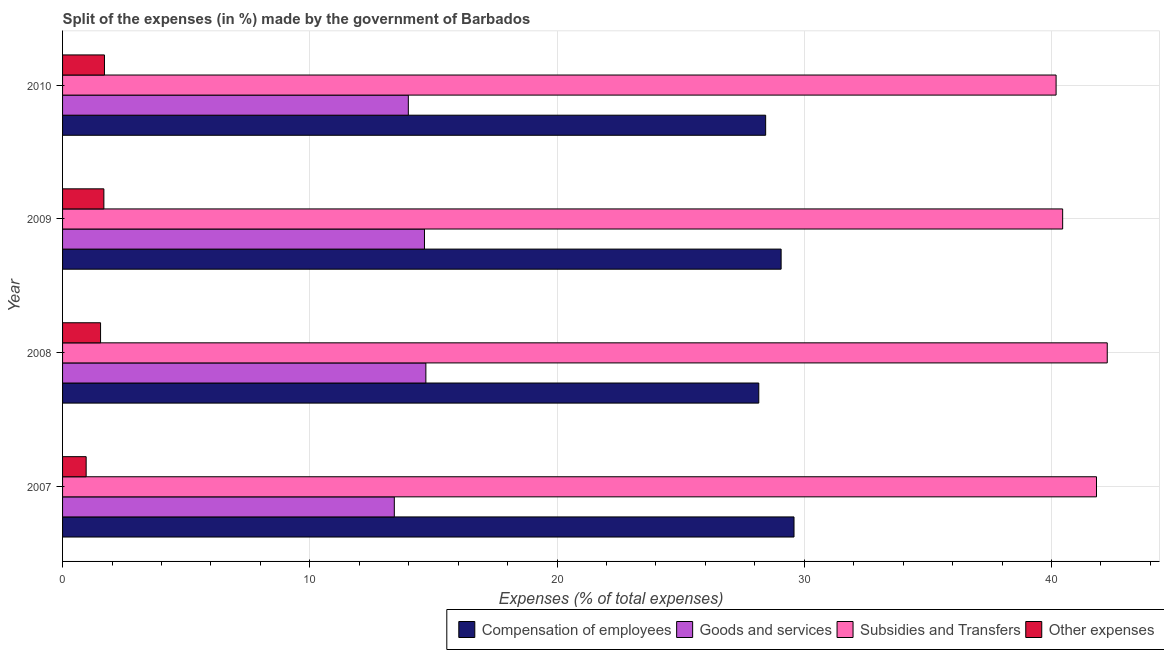How many groups of bars are there?
Offer a very short reply. 4. Are the number of bars per tick equal to the number of legend labels?
Ensure brevity in your answer.  Yes. Are the number of bars on each tick of the Y-axis equal?
Your answer should be very brief. Yes. How many bars are there on the 2nd tick from the top?
Offer a very short reply. 4. What is the label of the 1st group of bars from the top?
Ensure brevity in your answer.  2010. What is the percentage of amount spent on goods and services in 2010?
Make the answer very short. 13.99. Across all years, what is the maximum percentage of amount spent on compensation of employees?
Provide a short and direct response. 29.59. Across all years, what is the minimum percentage of amount spent on other expenses?
Provide a short and direct response. 0.95. What is the total percentage of amount spent on other expenses in the graph?
Offer a very short reply. 5.86. What is the difference between the percentage of amount spent on subsidies in 2008 and that in 2010?
Make the answer very short. 2.07. What is the difference between the percentage of amount spent on subsidies in 2009 and the percentage of amount spent on goods and services in 2008?
Keep it short and to the point. 25.76. What is the average percentage of amount spent on compensation of employees per year?
Keep it short and to the point. 28.81. In the year 2009, what is the difference between the percentage of amount spent on other expenses and percentage of amount spent on compensation of employees?
Keep it short and to the point. -27.39. What is the ratio of the percentage of amount spent on subsidies in 2007 to that in 2009?
Provide a succinct answer. 1.03. Is the percentage of amount spent on compensation of employees in 2007 less than that in 2009?
Provide a succinct answer. No. What is the difference between the highest and the second highest percentage of amount spent on goods and services?
Offer a terse response. 0.06. What is the difference between the highest and the lowest percentage of amount spent on goods and services?
Your response must be concise. 1.28. In how many years, is the percentage of amount spent on goods and services greater than the average percentage of amount spent on goods and services taken over all years?
Provide a succinct answer. 2. Is the sum of the percentage of amount spent on goods and services in 2009 and 2010 greater than the maximum percentage of amount spent on compensation of employees across all years?
Your response must be concise. No. What does the 1st bar from the top in 2008 represents?
Your answer should be very brief. Other expenses. What does the 3rd bar from the bottom in 2010 represents?
Your response must be concise. Subsidies and Transfers. Is it the case that in every year, the sum of the percentage of amount spent on compensation of employees and percentage of amount spent on goods and services is greater than the percentage of amount spent on subsidies?
Give a very brief answer. Yes. Are all the bars in the graph horizontal?
Your answer should be very brief. Yes. What is the difference between two consecutive major ticks on the X-axis?
Your response must be concise. 10. Are the values on the major ticks of X-axis written in scientific E-notation?
Offer a terse response. No. Does the graph contain grids?
Make the answer very short. Yes. Where does the legend appear in the graph?
Your answer should be very brief. Bottom right. How many legend labels are there?
Your answer should be compact. 4. How are the legend labels stacked?
Provide a short and direct response. Horizontal. What is the title of the graph?
Make the answer very short. Split of the expenses (in %) made by the government of Barbados. What is the label or title of the X-axis?
Your answer should be compact. Expenses (% of total expenses). What is the label or title of the Y-axis?
Make the answer very short. Year. What is the Expenses (% of total expenses) of Compensation of employees in 2007?
Your answer should be compact. 29.59. What is the Expenses (% of total expenses) of Goods and services in 2007?
Your answer should be compact. 13.42. What is the Expenses (% of total expenses) in Subsidies and Transfers in 2007?
Provide a succinct answer. 41.82. What is the Expenses (% of total expenses) of Other expenses in 2007?
Give a very brief answer. 0.95. What is the Expenses (% of total expenses) of Compensation of employees in 2008?
Your answer should be compact. 28.16. What is the Expenses (% of total expenses) of Goods and services in 2008?
Your answer should be very brief. 14.69. What is the Expenses (% of total expenses) of Subsidies and Transfers in 2008?
Ensure brevity in your answer.  42.26. What is the Expenses (% of total expenses) of Other expenses in 2008?
Your response must be concise. 1.54. What is the Expenses (% of total expenses) of Compensation of employees in 2009?
Give a very brief answer. 29.06. What is the Expenses (% of total expenses) in Goods and services in 2009?
Provide a short and direct response. 14.64. What is the Expenses (% of total expenses) of Subsidies and Transfers in 2009?
Provide a succinct answer. 40.45. What is the Expenses (% of total expenses) of Other expenses in 2009?
Your answer should be compact. 1.67. What is the Expenses (% of total expenses) in Compensation of employees in 2010?
Provide a short and direct response. 28.44. What is the Expenses (% of total expenses) of Goods and services in 2010?
Provide a short and direct response. 13.99. What is the Expenses (% of total expenses) in Subsidies and Transfers in 2010?
Offer a very short reply. 40.19. What is the Expenses (% of total expenses) in Other expenses in 2010?
Provide a short and direct response. 1.69. Across all years, what is the maximum Expenses (% of total expenses) in Compensation of employees?
Ensure brevity in your answer.  29.59. Across all years, what is the maximum Expenses (% of total expenses) of Goods and services?
Your answer should be compact. 14.69. Across all years, what is the maximum Expenses (% of total expenses) in Subsidies and Transfers?
Give a very brief answer. 42.26. Across all years, what is the maximum Expenses (% of total expenses) of Other expenses?
Ensure brevity in your answer.  1.69. Across all years, what is the minimum Expenses (% of total expenses) in Compensation of employees?
Ensure brevity in your answer.  28.16. Across all years, what is the minimum Expenses (% of total expenses) of Goods and services?
Provide a succinct answer. 13.42. Across all years, what is the minimum Expenses (% of total expenses) in Subsidies and Transfers?
Keep it short and to the point. 40.19. Across all years, what is the minimum Expenses (% of total expenses) in Other expenses?
Provide a short and direct response. 0.95. What is the total Expenses (% of total expenses) of Compensation of employees in the graph?
Provide a succinct answer. 115.25. What is the total Expenses (% of total expenses) in Goods and services in the graph?
Make the answer very short. 56.74. What is the total Expenses (% of total expenses) of Subsidies and Transfers in the graph?
Offer a terse response. 164.71. What is the total Expenses (% of total expenses) of Other expenses in the graph?
Make the answer very short. 5.86. What is the difference between the Expenses (% of total expenses) in Compensation of employees in 2007 and that in 2008?
Ensure brevity in your answer.  1.43. What is the difference between the Expenses (% of total expenses) in Goods and services in 2007 and that in 2008?
Ensure brevity in your answer.  -1.28. What is the difference between the Expenses (% of total expenses) in Subsidies and Transfers in 2007 and that in 2008?
Offer a very short reply. -0.44. What is the difference between the Expenses (% of total expenses) of Other expenses in 2007 and that in 2008?
Provide a short and direct response. -0.58. What is the difference between the Expenses (% of total expenses) in Compensation of employees in 2007 and that in 2009?
Keep it short and to the point. 0.52. What is the difference between the Expenses (% of total expenses) of Goods and services in 2007 and that in 2009?
Your answer should be compact. -1.22. What is the difference between the Expenses (% of total expenses) in Subsidies and Transfers in 2007 and that in 2009?
Offer a very short reply. 1.37. What is the difference between the Expenses (% of total expenses) of Other expenses in 2007 and that in 2009?
Provide a succinct answer. -0.72. What is the difference between the Expenses (% of total expenses) in Compensation of employees in 2007 and that in 2010?
Offer a terse response. 1.15. What is the difference between the Expenses (% of total expenses) in Goods and services in 2007 and that in 2010?
Give a very brief answer. -0.57. What is the difference between the Expenses (% of total expenses) of Subsidies and Transfers in 2007 and that in 2010?
Give a very brief answer. 1.63. What is the difference between the Expenses (% of total expenses) in Other expenses in 2007 and that in 2010?
Ensure brevity in your answer.  -0.74. What is the difference between the Expenses (% of total expenses) in Compensation of employees in 2008 and that in 2009?
Your answer should be compact. -0.9. What is the difference between the Expenses (% of total expenses) of Goods and services in 2008 and that in 2009?
Keep it short and to the point. 0.06. What is the difference between the Expenses (% of total expenses) in Subsidies and Transfers in 2008 and that in 2009?
Make the answer very short. 1.8. What is the difference between the Expenses (% of total expenses) of Other expenses in 2008 and that in 2009?
Make the answer very short. -0.13. What is the difference between the Expenses (% of total expenses) of Compensation of employees in 2008 and that in 2010?
Provide a succinct answer. -0.28. What is the difference between the Expenses (% of total expenses) in Goods and services in 2008 and that in 2010?
Keep it short and to the point. 0.71. What is the difference between the Expenses (% of total expenses) of Subsidies and Transfers in 2008 and that in 2010?
Keep it short and to the point. 2.07. What is the difference between the Expenses (% of total expenses) of Other expenses in 2008 and that in 2010?
Offer a very short reply. -0.16. What is the difference between the Expenses (% of total expenses) of Compensation of employees in 2009 and that in 2010?
Ensure brevity in your answer.  0.63. What is the difference between the Expenses (% of total expenses) of Goods and services in 2009 and that in 2010?
Ensure brevity in your answer.  0.65. What is the difference between the Expenses (% of total expenses) in Subsidies and Transfers in 2009 and that in 2010?
Keep it short and to the point. 0.27. What is the difference between the Expenses (% of total expenses) in Other expenses in 2009 and that in 2010?
Provide a short and direct response. -0.02. What is the difference between the Expenses (% of total expenses) in Compensation of employees in 2007 and the Expenses (% of total expenses) in Goods and services in 2008?
Provide a succinct answer. 14.89. What is the difference between the Expenses (% of total expenses) of Compensation of employees in 2007 and the Expenses (% of total expenses) of Subsidies and Transfers in 2008?
Offer a terse response. -12.67. What is the difference between the Expenses (% of total expenses) in Compensation of employees in 2007 and the Expenses (% of total expenses) in Other expenses in 2008?
Make the answer very short. 28.05. What is the difference between the Expenses (% of total expenses) in Goods and services in 2007 and the Expenses (% of total expenses) in Subsidies and Transfers in 2008?
Make the answer very short. -28.84. What is the difference between the Expenses (% of total expenses) of Goods and services in 2007 and the Expenses (% of total expenses) of Other expenses in 2008?
Provide a short and direct response. 11.88. What is the difference between the Expenses (% of total expenses) in Subsidies and Transfers in 2007 and the Expenses (% of total expenses) in Other expenses in 2008?
Make the answer very short. 40.28. What is the difference between the Expenses (% of total expenses) of Compensation of employees in 2007 and the Expenses (% of total expenses) of Goods and services in 2009?
Offer a terse response. 14.95. What is the difference between the Expenses (% of total expenses) of Compensation of employees in 2007 and the Expenses (% of total expenses) of Subsidies and Transfers in 2009?
Your answer should be very brief. -10.87. What is the difference between the Expenses (% of total expenses) in Compensation of employees in 2007 and the Expenses (% of total expenses) in Other expenses in 2009?
Your answer should be very brief. 27.91. What is the difference between the Expenses (% of total expenses) in Goods and services in 2007 and the Expenses (% of total expenses) in Subsidies and Transfers in 2009?
Provide a succinct answer. -27.03. What is the difference between the Expenses (% of total expenses) in Goods and services in 2007 and the Expenses (% of total expenses) in Other expenses in 2009?
Ensure brevity in your answer.  11.75. What is the difference between the Expenses (% of total expenses) of Subsidies and Transfers in 2007 and the Expenses (% of total expenses) of Other expenses in 2009?
Ensure brevity in your answer.  40.15. What is the difference between the Expenses (% of total expenses) of Compensation of employees in 2007 and the Expenses (% of total expenses) of Goods and services in 2010?
Your response must be concise. 15.6. What is the difference between the Expenses (% of total expenses) of Compensation of employees in 2007 and the Expenses (% of total expenses) of Subsidies and Transfers in 2010?
Your answer should be very brief. -10.6. What is the difference between the Expenses (% of total expenses) of Compensation of employees in 2007 and the Expenses (% of total expenses) of Other expenses in 2010?
Offer a terse response. 27.89. What is the difference between the Expenses (% of total expenses) in Goods and services in 2007 and the Expenses (% of total expenses) in Subsidies and Transfers in 2010?
Your response must be concise. -26.77. What is the difference between the Expenses (% of total expenses) in Goods and services in 2007 and the Expenses (% of total expenses) in Other expenses in 2010?
Offer a very short reply. 11.72. What is the difference between the Expenses (% of total expenses) in Subsidies and Transfers in 2007 and the Expenses (% of total expenses) in Other expenses in 2010?
Keep it short and to the point. 40.13. What is the difference between the Expenses (% of total expenses) of Compensation of employees in 2008 and the Expenses (% of total expenses) of Goods and services in 2009?
Give a very brief answer. 13.52. What is the difference between the Expenses (% of total expenses) of Compensation of employees in 2008 and the Expenses (% of total expenses) of Subsidies and Transfers in 2009?
Your answer should be very brief. -12.29. What is the difference between the Expenses (% of total expenses) of Compensation of employees in 2008 and the Expenses (% of total expenses) of Other expenses in 2009?
Your response must be concise. 26.49. What is the difference between the Expenses (% of total expenses) in Goods and services in 2008 and the Expenses (% of total expenses) in Subsidies and Transfers in 2009?
Offer a very short reply. -25.76. What is the difference between the Expenses (% of total expenses) in Goods and services in 2008 and the Expenses (% of total expenses) in Other expenses in 2009?
Keep it short and to the point. 13.02. What is the difference between the Expenses (% of total expenses) of Subsidies and Transfers in 2008 and the Expenses (% of total expenses) of Other expenses in 2009?
Offer a terse response. 40.58. What is the difference between the Expenses (% of total expenses) of Compensation of employees in 2008 and the Expenses (% of total expenses) of Goods and services in 2010?
Offer a terse response. 14.17. What is the difference between the Expenses (% of total expenses) in Compensation of employees in 2008 and the Expenses (% of total expenses) in Subsidies and Transfers in 2010?
Provide a short and direct response. -12.03. What is the difference between the Expenses (% of total expenses) of Compensation of employees in 2008 and the Expenses (% of total expenses) of Other expenses in 2010?
Keep it short and to the point. 26.47. What is the difference between the Expenses (% of total expenses) in Goods and services in 2008 and the Expenses (% of total expenses) in Subsidies and Transfers in 2010?
Offer a very short reply. -25.49. What is the difference between the Expenses (% of total expenses) of Goods and services in 2008 and the Expenses (% of total expenses) of Other expenses in 2010?
Offer a terse response. 13. What is the difference between the Expenses (% of total expenses) of Subsidies and Transfers in 2008 and the Expenses (% of total expenses) of Other expenses in 2010?
Provide a succinct answer. 40.56. What is the difference between the Expenses (% of total expenses) in Compensation of employees in 2009 and the Expenses (% of total expenses) in Goods and services in 2010?
Offer a very short reply. 15.08. What is the difference between the Expenses (% of total expenses) of Compensation of employees in 2009 and the Expenses (% of total expenses) of Subsidies and Transfers in 2010?
Ensure brevity in your answer.  -11.12. What is the difference between the Expenses (% of total expenses) in Compensation of employees in 2009 and the Expenses (% of total expenses) in Other expenses in 2010?
Ensure brevity in your answer.  27.37. What is the difference between the Expenses (% of total expenses) of Goods and services in 2009 and the Expenses (% of total expenses) of Subsidies and Transfers in 2010?
Give a very brief answer. -25.55. What is the difference between the Expenses (% of total expenses) in Goods and services in 2009 and the Expenses (% of total expenses) in Other expenses in 2010?
Your response must be concise. 12.94. What is the difference between the Expenses (% of total expenses) of Subsidies and Transfers in 2009 and the Expenses (% of total expenses) of Other expenses in 2010?
Offer a very short reply. 38.76. What is the average Expenses (% of total expenses) of Compensation of employees per year?
Give a very brief answer. 28.81. What is the average Expenses (% of total expenses) in Goods and services per year?
Your answer should be compact. 14.18. What is the average Expenses (% of total expenses) of Subsidies and Transfers per year?
Ensure brevity in your answer.  41.18. What is the average Expenses (% of total expenses) in Other expenses per year?
Offer a terse response. 1.46. In the year 2007, what is the difference between the Expenses (% of total expenses) of Compensation of employees and Expenses (% of total expenses) of Goods and services?
Ensure brevity in your answer.  16.17. In the year 2007, what is the difference between the Expenses (% of total expenses) in Compensation of employees and Expenses (% of total expenses) in Subsidies and Transfers?
Offer a terse response. -12.23. In the year 2007, what is the difference between the Expenses (% of total expenses) in Compensation of employees and Expenses (% of total expenses) in Other expenses?
Offer a very short reply. 28.63. In the year 2007, what is the difference between the Expenses (% of total expenses) of Goods and services and Expenses (% of total expenses) of Subsidies and Transfers?
Give a very brief answer. -28.4. In the year 2007, what is the difference between the Expenses (% of total expenses) of Goods and services and Expenses (% of total expenses) of Other expenses?
Your response must be concise. 12.46. In the year 2007, what is the difference between the Expenses (% of total expenses) of Subsidies and Transfers and Expenses (% of total expenses) of Other expenses?
Provide a short and direct response. 40.87. In the year 2008, what is the difference between the Expenses (% of total expenses) in Compensation of employees and Expenses (% of total expenses) in Goods and services?
Provide a short and direct response. 13.47. In the year 2008, what is the difference between the Expenses (% of total expenses) in Compensation of employees and Expenses (% of total expenses) in Subsidies and Transfers?
Make the answer very short. -14.1. In the year 2008, what is the difference between the Expenses (% of total expenses) in Compensation of employees and Expenses (% of total expenses) in Other expenses?
Keep it short and to the point. 26.62. In the year 2008, what is the difference between the Expenses (% of total expenses) in Goods and services and Expenses (% of total expenses) in Subsidies and Transfers?
Offer a terse response. -27.56. In the year 2008, what is the difference between the Expenses (% of total expenses) of Goods and services and Expenses (% of total expenses) of Other expenses?
Your answer should be compact. 13.16. In the year 2008, what is the difference between the Expenses (% of total expenses) of Subsidies and Transfers and Expenses (% of total expenses) of Other expenses?
Offer a very short reply. 40.72. In the year 2009, what is the difference between the Expenses (% of total expenses) in Compensation of employees and Expenses (% of total expenses) in Goods and services?
Make the answer very short. 14.43. In the year 2009, what is the difference between the Expenses (% of total expenses) of Compensation of employees and Expenses (% of total expenses) of Subsidies and Transfers?
Provide a succinct answer. -11.39. In the year 2009, what is the difference between the Expenses (% of total expenses) of Compensation of employees and Expenses (% of total expenses) of Other expenses?
Offer a terse response. 27.39. In the year 2009, what is the difference between the Expenses (% of total expenses) of Goods and services and Expenses (% of total expenses) of Subsidies and Transfers?
Your answer should be compact. -25.81. In the year 2009, what is the difference between the Expenses (% of total expenses) of Goods and services and Expenses (% of total expenses) of Other expenses?
Make the answer very short. 12.97. In the year 2009, what is the difference between the Expenses (% of total expenses) of Subsidies and Transfers and Expenses (% of total expenses) of Other expenses?
Offer a terse response. 38.78. In the year 2010, what is the difference between the Expenses (% of total expenses) of Compensation of employees and Expenses (% of total expenses) of Goods and services?
Provide a short and direct response. 14.45. In the year 2010, what is the difference between the Expenses (% of total expenses) of Compensation of employees and Expenses (% of total expenses) of Subsidies and Transfers?
Offer a terse response. -11.75. In the year 2010, what is the difference between the Expenses (% of total expenses) in Compensation of employees and Expenses (% of total expenses) in Other expenses?
Provide a short and direct response. 26.74. In the year 2010, what is the difference between the Expenses (% of total expenses) of Goods and services and Expenses (% of total expenses) of Subsidies and Transfers?
Your answer should be compact. -26.2. In the year 2010, what is the difference between the Expenses (% of total expenses) of Goods and services and Expenses (% of total expenses) of Other expenses?
Offer a terse response. 12.29. In the year 2010, what is the difference between the Expenses (% of total expenses) in Subsidies and Transfers and Expenses (% of total expenses) in Other expenses?
Offer a terse response. 38.49. What is the ratio of the Expenses (% of total expenses) in Compensation of employees in 2007 to that in 2008?
Your answer should be compact. 1.05. What is the ratio of the Expenses (% of total expenses) in Goods and services in 2007 to that in 2008?
Make the answer very short. 0.91. What is the ratio of the Expenses (% of total expenses) of Subsidies and Transfers in 2007 to that in 2008?
Your response must be concise. 0.99. What is the ratio of the Expenses (% of total expenses) of Other expenses in 2007 to that in 2008?
Keep it short and to the point. 0.62. What is the ratio of the Expenses (% of total expenses) in Compensation of employees in 2007 to that in 2009?
Make the answer very short. 1.02. What is the ratio of the Expenses (% of total expenses) of Goods and services in 2007 to that in 2009?
Your answer should be very brief. 0.92. What is the ratio of the Expenses (% of total expenses) in Subsidies and Transfers in 2007 to that in 2009?
Offer a very short reply. 1.03. What is the ratio of the Expenses (% of total expenses) in Other expenses in 2007 to that in 2009?
Make the answer very short. 0.57. What is the ratio of the Expenses (% of total expenses) of Compensation of employees in 2007 to that in 2010?
Provide a succinct answer. 1.04. What is the ratio of the Expenses (% of total expenses) in Goods and services in 2007 to that in 2010?
Provide a short and direct response. 0.96. What is the ratio of the Expenses (% of total expenses) in Subsidies and Transfers in 2007 to that in 2010?
Provide a short and direct response. 1.04. What is the ratio of the Expenses (% of total expenses) of Other expenses in 2007 to that in 2010?
Your response must be concise. 0.56. What is the ratio of the Expenses (% of total expenses) in Compensation of employees in 2008 to that in 2009?
Offer a terse response. 0.97. What is the ratio of the Expenses (% of total expenses) in Subsidies and Transfers in 2008 to that in 2009?
Your answer should be very brief. 1.04. What is the ratio of the Expenses (% of total expenses) of Other expenses in 2008 to that in 2009?
Offer a very short reply. 0.92. What is the ratio of the Expenses (% of total expenses) of Compensation of employees in 2008 to that in 2010?
Your answer should be very brief. 0.99. What is the ratio of the Expenses (% of total expenses) of Goods and services in 2008 to that in 2010?
Ensure brevity in your answer.  1.05. What is the ratio of the Expenses (% of total expenses) in Subsidies and Transfers in 2008 to that in 2010?
Your response must be concise. 1.05. What is the ratio of the Expenses (% of total expenses) of Other expenses in 2008 to that in 2010?
Your answer should be compact. 0.91. What is the ratio of the Expenses (% of total expenses) in Compensation of employees in 2009 to that in 2010?
Provide a succinct answer. 1.02. What is the ratio of the Expenses (% of total expenses) in Goods and services in 2009 to that in 2010?
Provide a short and direct response. 1.05. What is the ratio of the Expenses (% of total expenses) in Subsidies and Transfers in 2009 to that in 2010?
Give a very brief answer. 1.01. What is the ratio of the Expenses (% of total expenses) of Other expenses in 2009 to that in 2010?
Give a very brief answer. 0.99. What is the difference between the highest and the second highest Expenses (% of total expenses) in Compensation of employees?
Your response must be concise. 0.52. What is the difference between the highest and the second highest Expenses (% of total expenses) of Goods and services?
Provide a short and direct response. 0.06. What is the difference between the highest and the second highest Expenses (% of total expenses) of Subsidies and Transfers?
Provide a succinct answer. 0.44. What is the difference between the highest and the second highest Expenses (% of total expenses) of Other expenses?
Offer a very short reply. 0.02. What is the difference between the highest and the lowest Expenses (% of total expenses) of Compensation of employees?
Keep it short and to the point. 1.43. What is the difference between the highest and the lowest Expenses (% of total expenses) of Goods and services?
Offer a terse response. 1.28. What is the difference between the highest and the lowest Expenses (% of total expenses) in Subsidies and Transfers?
Your answer should be very brief. 2.07. What is the difference between the highest and the lowest Expenses (% of total expenses) in Other expenses?
Provide a short and direct response. 0.74. 